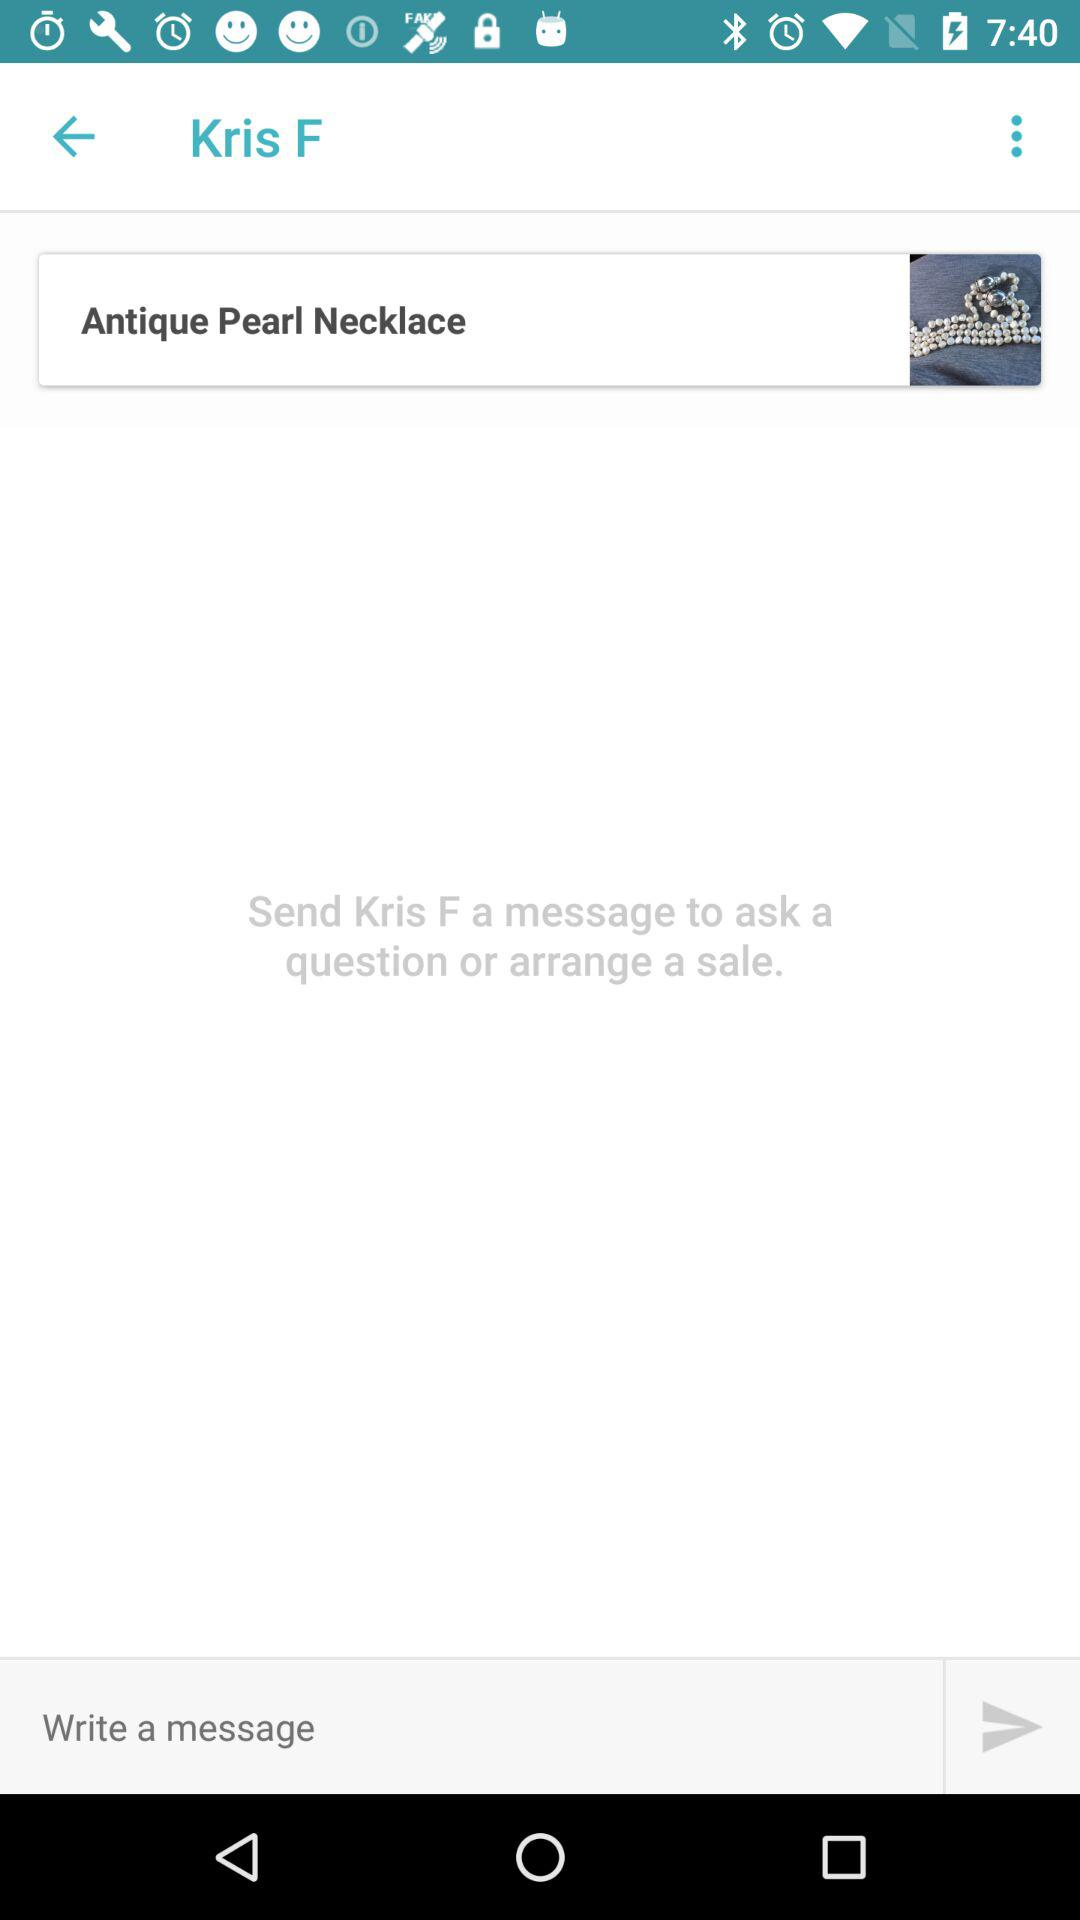To whom should I send a message to arrange a sale? You should send a message to Kris F. 